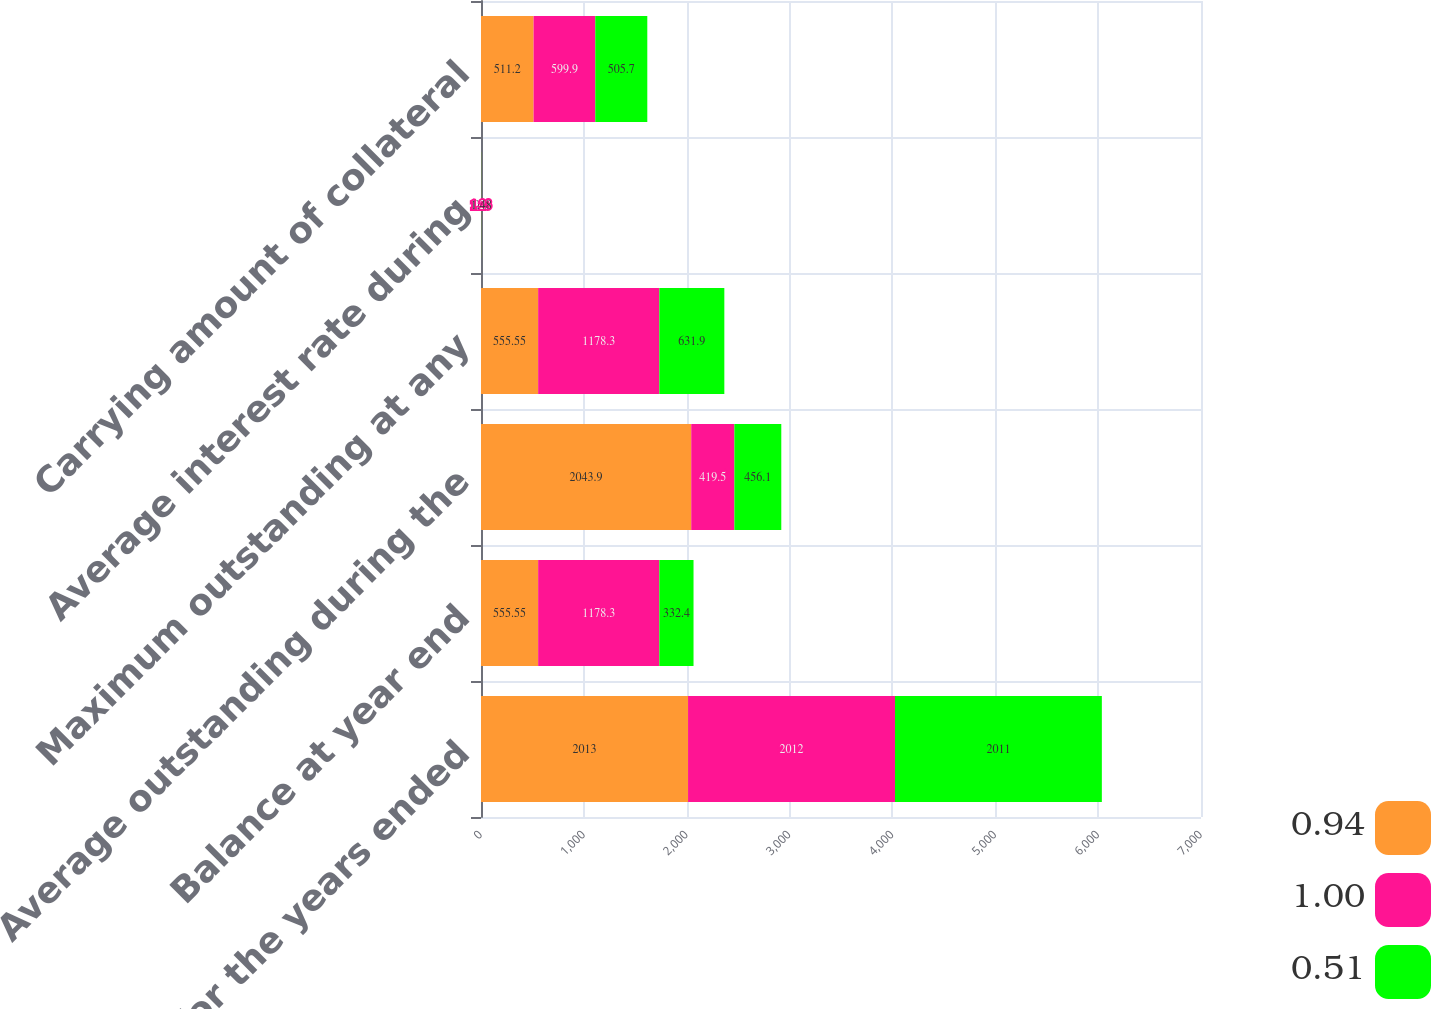Convert chart to OTSL. <chart><loc_0><loc_0><loc_500><loc_500><stacked_bar_chart><ecel><fcel>As of and for the years ended<fcel>Balance at year end<fcel>Average outstanding during the<fcel>Maximum outstanding at any<fcel>Average interest rate during<fcel>Carrying amount of collateral<nl><fcel>0.94<fcel>2013<fcel>555.55<fcel>2043.9<fcel>555.55<fcel>0.4<fcel>511.2<nl><fcel>1<fcel>2012<fcel>1178.3<fcel>419.5<fcel>1178.3<fcel>1.23<fcel>599.9<nl><fcel>0.51<fcel>2011<fcel>332.4<fcel>456.1<fcel>631.9<fcel>1.48<fcel>505.7<nl></chart> 